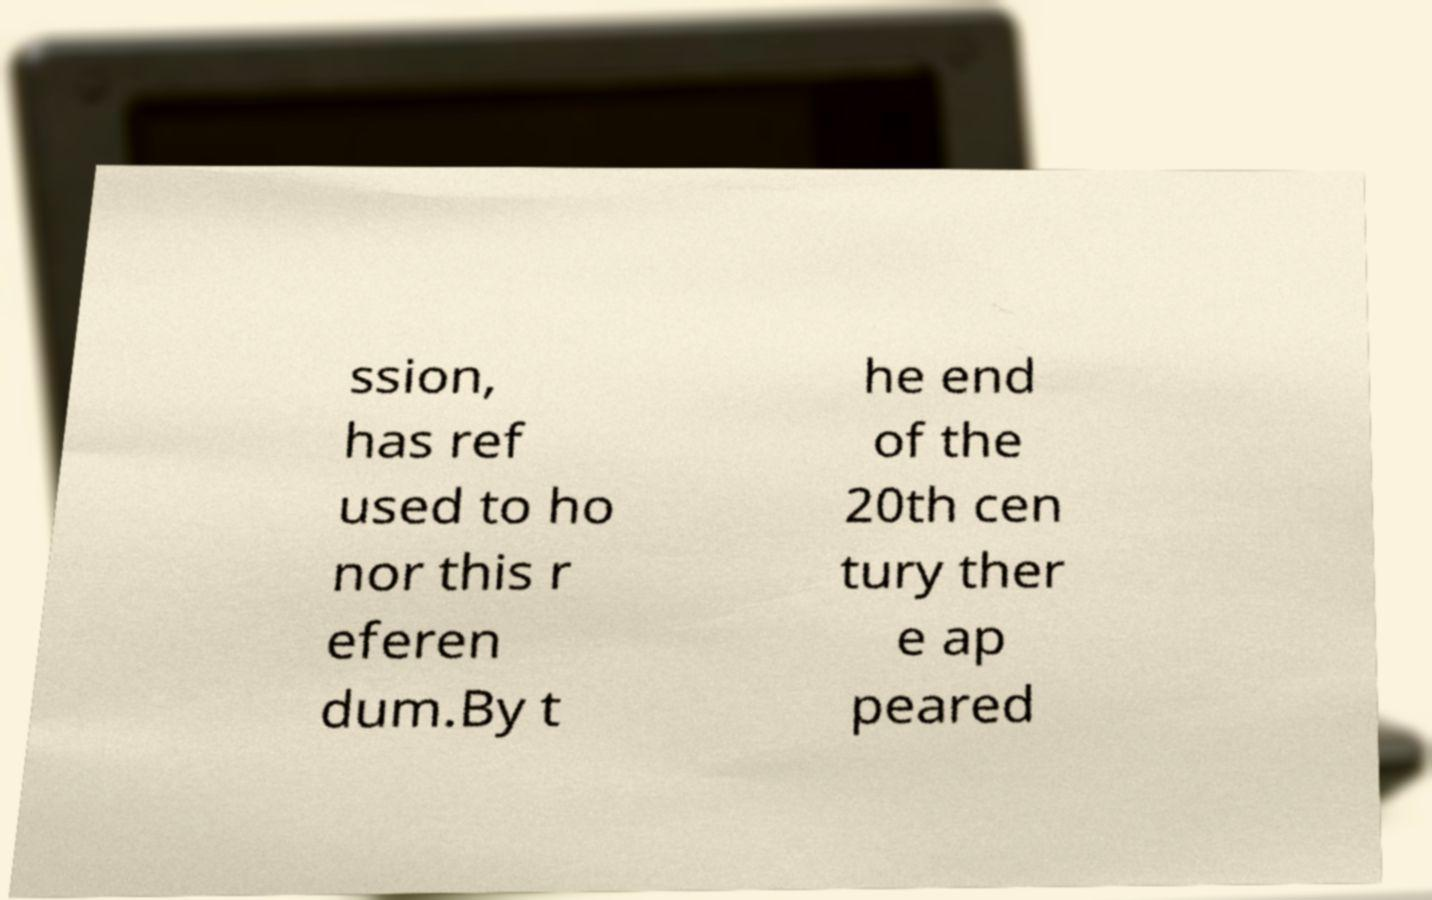Can you read and provide the text displayed in the image?This photo seems to have some interesting text. Can you extract and type it out for me? ssion, has ref used to ho nor this r eferen dum.By t he end of the 20th cen tury ther e ap peared 